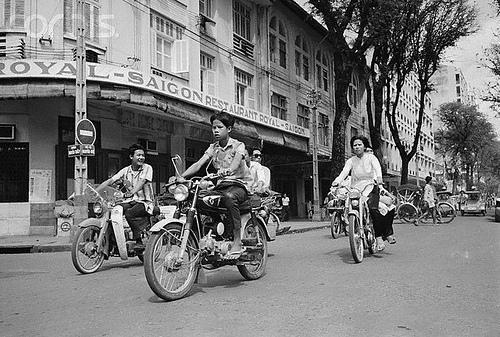How many bikes have two riders?
Give a very brief answer. 2. How many women do you see in the picture?
Give a very brief answer. 2. 